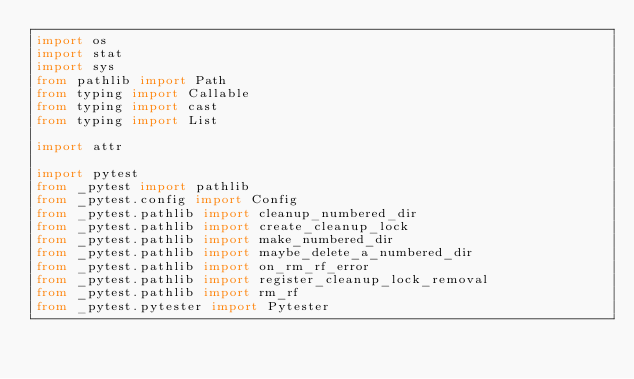Convert code to text. <code><loc_0><loc_0><loc_500><loc_500><_Python_>import os
import stat
import sys
from pathlib import Path
from typing import Callable
from typing import cast
from typing import List

import attr

import pytest
from _pytest import pathlib
from _pytest.config import Config
from _pytest.pathlib import cleanup_numbered_dir
from _pytest.pathlib import create_cleanup_lock
from _pytest.pathlib import make_numbered_dir
from _pytest.pathlib import maybe_delete_a_numbered_dir
from _pytest.pathlib import on_rm_rf_error
from _pytest.pathlib import register_cleanup_lock_removal
from _pytest.pathlib import rm_rf
from _pytest.pytester import Pytester</code> 